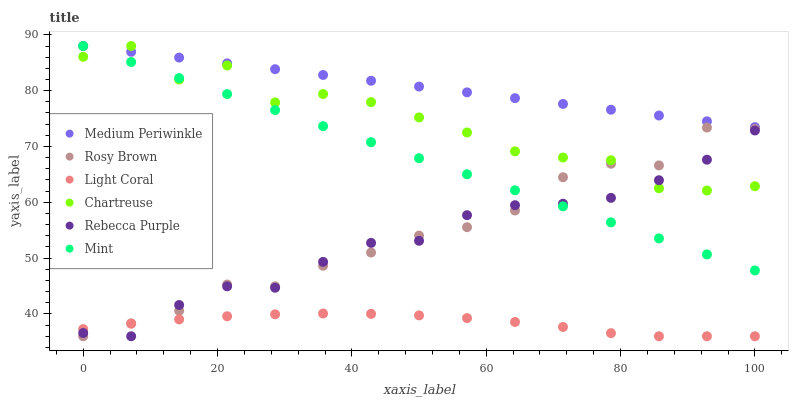Does Light Coral have the minimum area under the curve?
Answer yes or no. Yes. Does Medium Periwinkle have the maximum area under the curve?
Answer yes or no. Yes. Does Medium Periwinkle have the minimum area under the curve?
Answer yes or no. No. Does Light Coral have the maximum area under the curve?
Answer yes or no. No. Is Medium Periwinkle the smoothest?
Answer yes or no. Yes. Is Chartreuse the roughest?
Answer yes or no. Yes. Is Light Coral the smoothest?
Answer yes or no. No. Is Light Coral the roughest?
Answer yes or no. No. Does Rosy Brown have the lowest value?
Answer yes or no. Yes. Does Medium Periwinkle have the lowest value?
Answer yes or no. No. Does Mint have the highest value?
Answer yes or no. Yes. Does Light Coral have the highest value?
Answer yes or no. No. Is Rosy Brown less than Medium Periwinkle?
Answer yes or no. Yes. Is Mint greater than Light Coral?
Answer yes or no. Yes. Does Chartreuse intersect Medium Periwinkle?
Answer yes or no. Yes. Is Chartreuse less than Medium Periwinkle?
Answer yes or no. No. Is Chartreuse greater than Medium Periwinkle?
Answer yes or no. No. Does Rosy Brown intersect Medium Periwinkle?
Answer yes or no. No. 